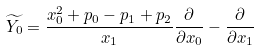Convert formula to latex. <formula><loc_0><loc_0><loc_500><loc_500>\widetilde { Y _ { 0 } } = \frac { x _ { 0 } ^ { 2 } + p _ { 0 } - p _ { 1 } + p _ { 2 } } { x _ { 1 } } \frac { \partial } { \partial x _ { 0 } } - \frac { \partial } { \partial x _ { 1 } }</formula> 